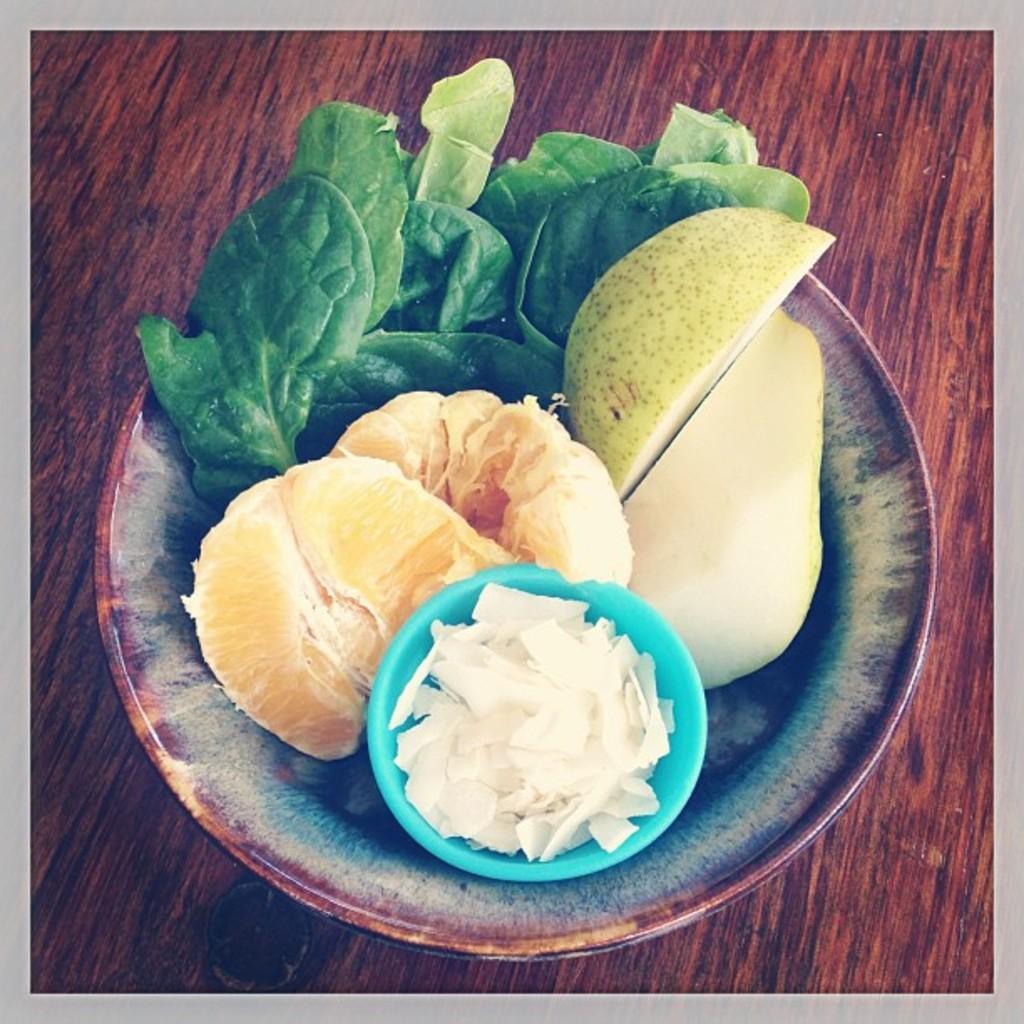Please provide a concise description of this image. The picture consists of a wooden table, on the table there is a bowl, in the bowl there are fruits, leaves and some other food items. 